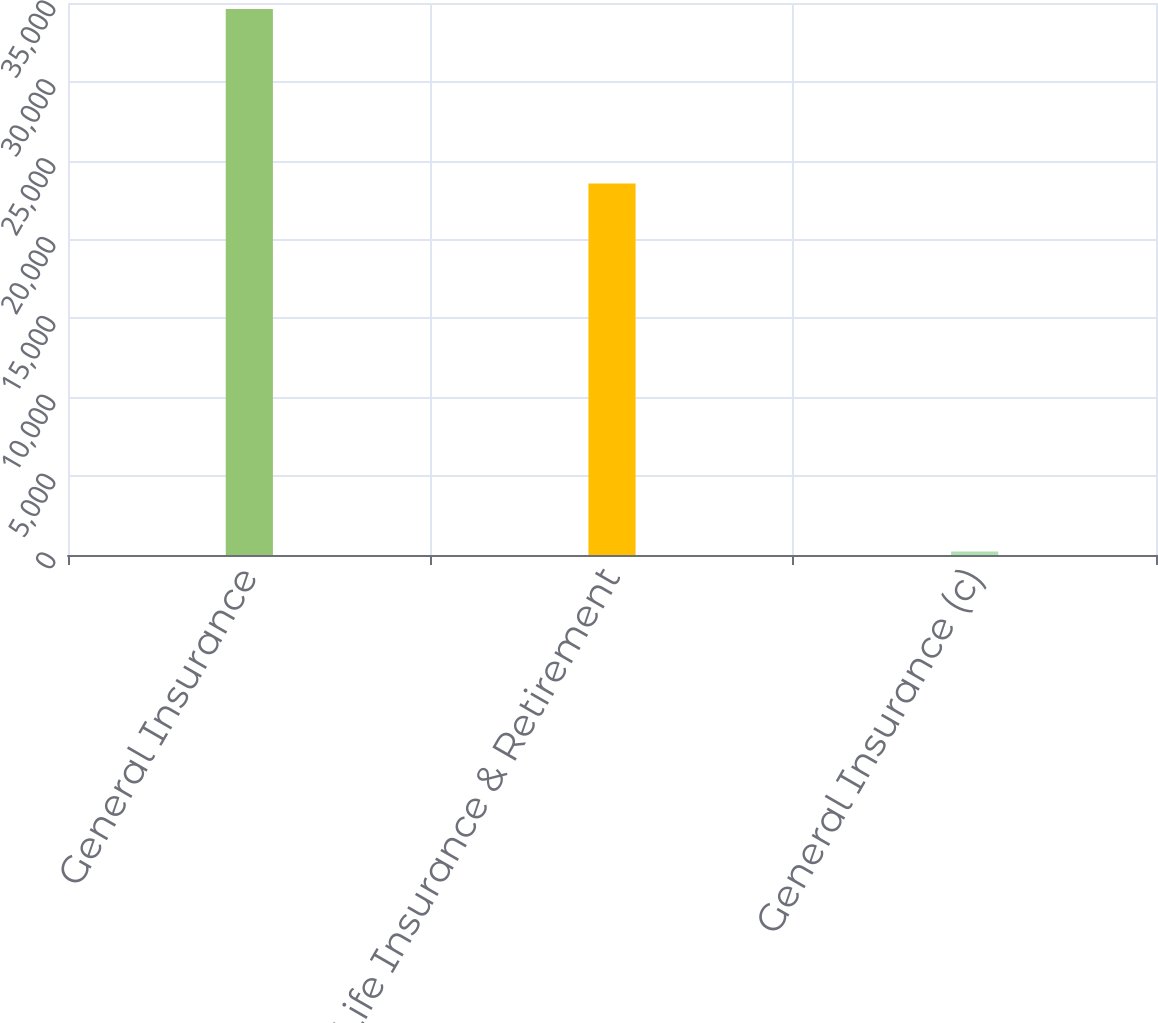Convert chart to OTSL. <chart><loc_0><loc_0><loc_500><loc_500><bar_chart><fcel>General Insurance<fcel>Life Insurance & Retirement<fcel>General Insurance (c)<nl><fcel>34616<fcel>23558<fcel>216<nl></chart> 